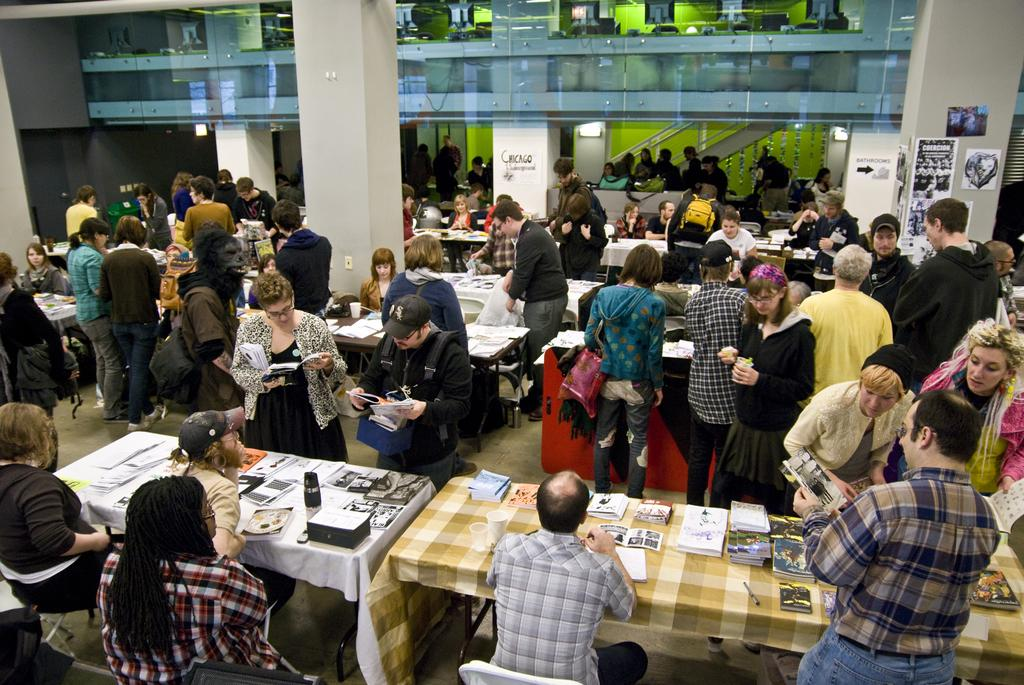How many people are in the image? There is a group of people in the image, but the exact number cannot be determined from the provided facts. What are the people in the image doing? Some people are sitting, while others are standing. What items can be seen on the table in the image? There are books and pens on the table. What is on the wall in the image? There are posters and hoardings on the wall. What architectural feature is visible in the image? There is a glass door in the image. How much control does the pipe have over the people in the image? There is no pipe present in the image, so it cannot have any control over the people. 